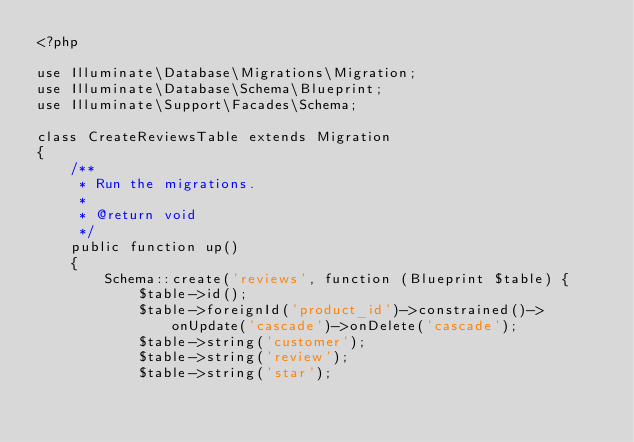<code> <loc_0><loc_0><loc_500><loc_500><_PHP_><?php

use Illuminate\Database\Migrations\Migration;
use Illuminate\Database\Schema\Blueprint;
use Illuminate\Support\Facades\Schema;

class CreateReviewsTable extends Migration
{
    /**
     * Run the migrations.
     *
     * @return void
     */
    public function up()
    {
        Schema::create('reviews', function (Blueprint $table) {
            $table->id();
            $table->foreignId('product_id')->constrained()->onUpdate('cascade')->onDelete('cascade');
            $table->string('customer');
            $table->string('review');
            $table->string('star');</code> 